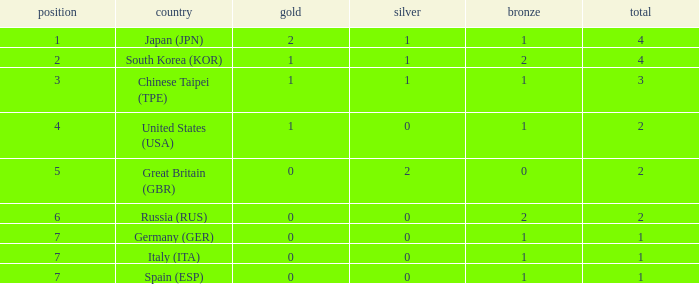What is the rank of the country with more than 2 medals, and 2 gold medals? 1.0. Could you help me parse every detail presented in this table? {'header': ['position', 'country', 'gold', 'silver', 'bronze', 'total'], 'rows': [['1', 'Japan (JPN)', '2', '1', '1', '4'], ['2', 'South Korea (KOR)', '1', '1', '2', '4'], ['3', 'Chinese Taipei (TPE)', '1', '1', '1', '3'], ['4', 'United States (USA)', '1', '0', '1', '2'], ['5', 'Great Britain (GBR)', '0', '2', '0', '2'], ['6', 'Russia (RUS)', '0', '0', '2', '2'], ['7', 'Germany (GER)', '0', '0', '1', '1'], ['7', 'Italy (ITA)', '0', '0', '1', '1'], ['7', 'Spain (ESP)', '0', '0', '1', '1']]} 